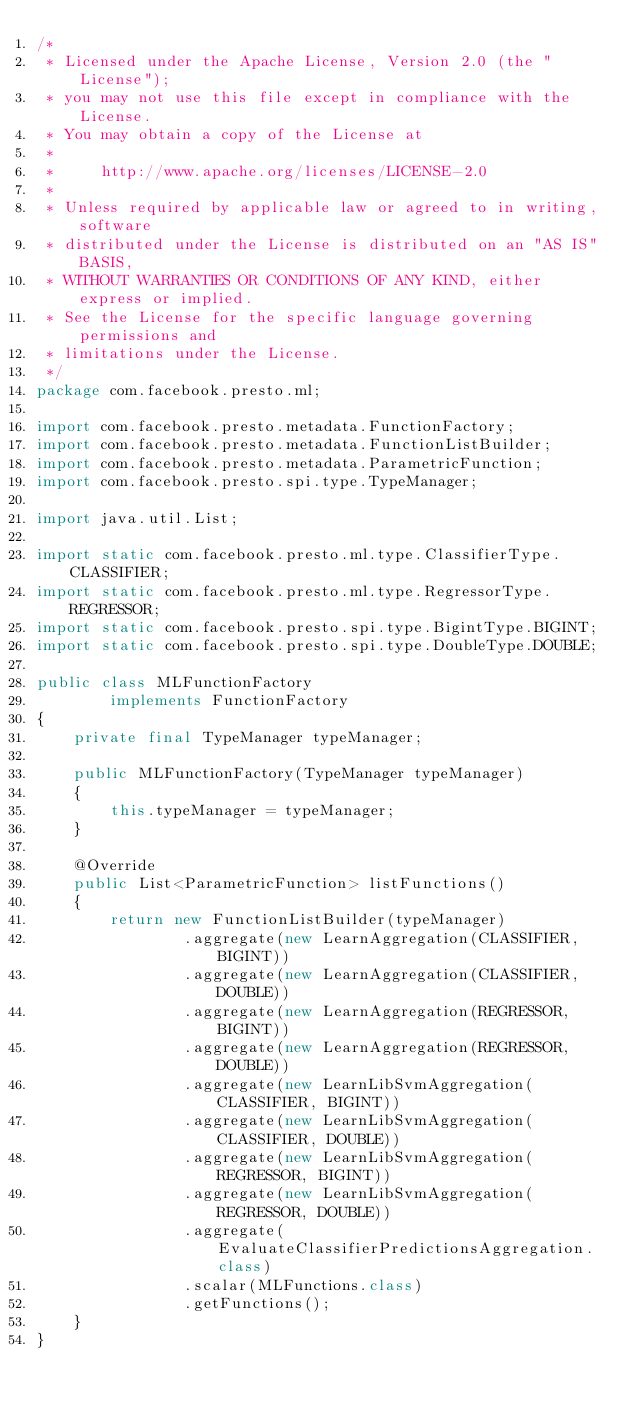Convert code to text. <code><loc_0><loc_0><loc_500><loc_500><_Java_>/*
 * Licensed under the Apache License, Version 2.0 (the "License");
 * you may not use this file except in compliance with the License.
 * You may obtain a copy of the License at
 *
 *     http://www.apache.org/licenses/LICENSE-2.0
 *
 * Unless required by applicable law or agreed to in writing, software
 * distributed under the License is distributed on an "AS IS" BASIS,
 * WITHOUT WARRANTIES OR CONDITIONS OF ANY KIND, either express or implied.
 * See the License for the specific language governing permissions and
 * limitations under the License.
 */
package com.facebook.presto.ml;

import com.facebook.presto.metadata.FunctionFactory;
import com.facebook.presto.metadata.FunctionListBuilder;
import com.facebook.presto.metadata.ParametricFunction;
import com.facebook.presto.spi.type.TypeManager;

import java.util.List;

import static com.facebook.presto.ml.type.ClassifierType.CLASSIFIER;
import static com.facebook.presto.ml.type.RegressorType.REGRESSOR;
import static com.facebook.presto.spi.type.BigintType.BIGINT;
import static com.facebook.presto.spi.type.DoubleType.DOUBLE;

public class MLFunctionFactory
        implements FunctionFactory
{
    private final TypeManager typeManager;

    public MLFunctionFactory(TypeManager typeManager)
    {
        this.typeManager = typeManager;
    }

    @Override
    public List<ParametricFunction> listFunctions()
    {
        return new FunctionListBuilder(typeManager)
                .aggregate(new LearnAggregation(CLASSIFIER, BIGINT))
                .aggregate(new LearnAggregation(CLASSIFIER, DOUBLE))
                .aggregate(new LearnAggregation(REGRESSOR, BIGINT))
                .aggregate(new LearnAggregation(REGRESSOR, DOUBLE))
                .aggregate(new LearnLibSvmAggregation(CLASSIFIER, BIGINT))
                .aggregate(new LearnLibSvmAggregation(CLASSIFIER, DOUBLE))
                .aggregate(new LearnLibSvmAggregation(REGRESSOR, BIGINT))
                .aggregate(new LearnLibSvmAggregation(REGRESSOR, DOUBLE))
                .aggregate(EvaluateClassifierPredictionsAggregation.class)
                .scalar(MLFunctions.class)
                .getFunctions();
    }
}
</code> 